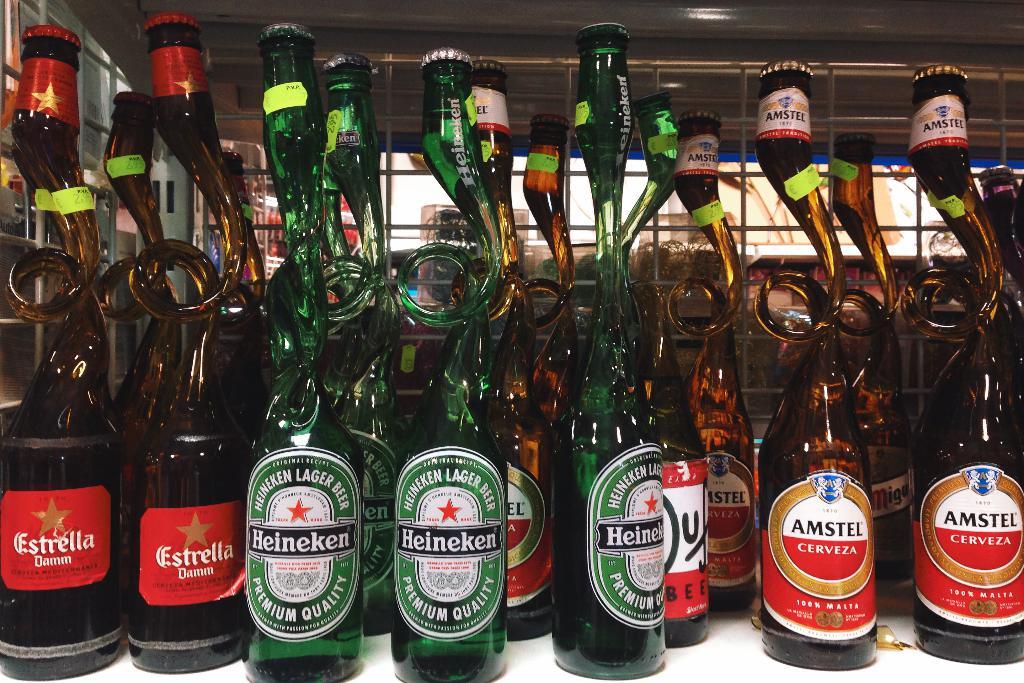What brand is the red labeled bottles on the left?
Your response must be concise. Estrella. 